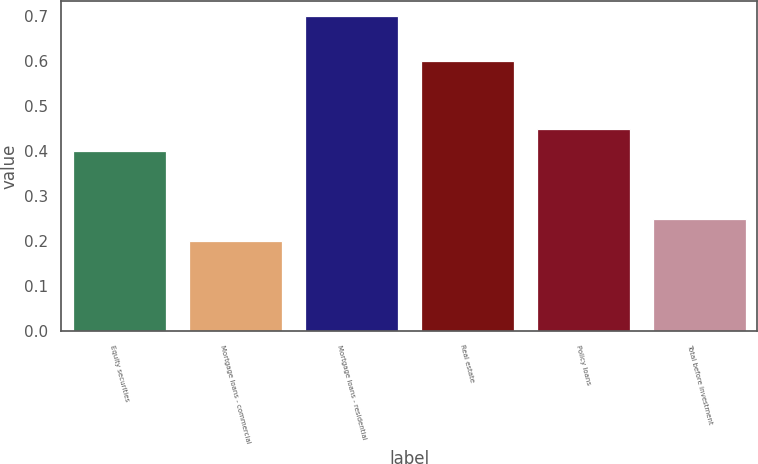Convert chart to OTSL. <chart><loc_0><loc_0><loc_500><loc_500><bar_chart><fcel>Equity securities<fcel>Mortgage loans - commercial<fcel>Mortgage loans - residential<fcel>Real estate<fcel>Policy loans<fcel>Total before investment<nl><fcel>0.4<fcel>0.2<fcel>0.7<fcel>0.6<fcel>0.45<fcel>0.25<nl></chart> 